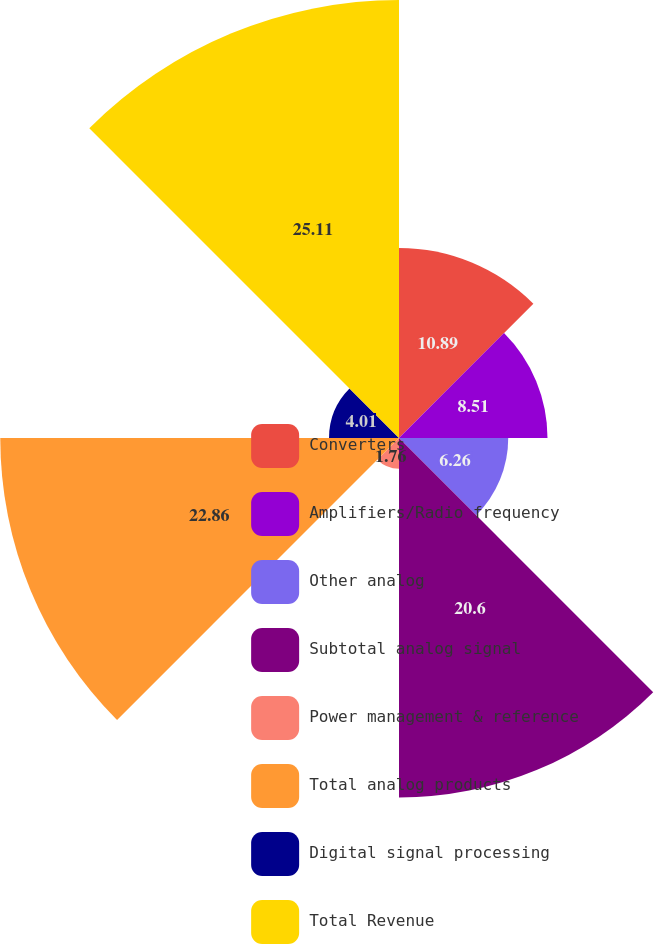Convert chart. <chart><loc_0><loc_0><loc_500><loc_500><pie_chart><fcel>Converters<fcel>Amplifiers/Radio frequency<fcel>Other analog<fcel>Subtotal analog signal<fcel>Power management & reference<fcel>Total analog products<fcel>Digital signal processing<fcel>Total Revenue<nl><fcel>10.89%<fcel>8.51%<fcel>6.26%<fcel>20.6%<fcel>1.76%<fcel>22.85%<fcel>4.01%<fcel>25.1%<nl></chart> 